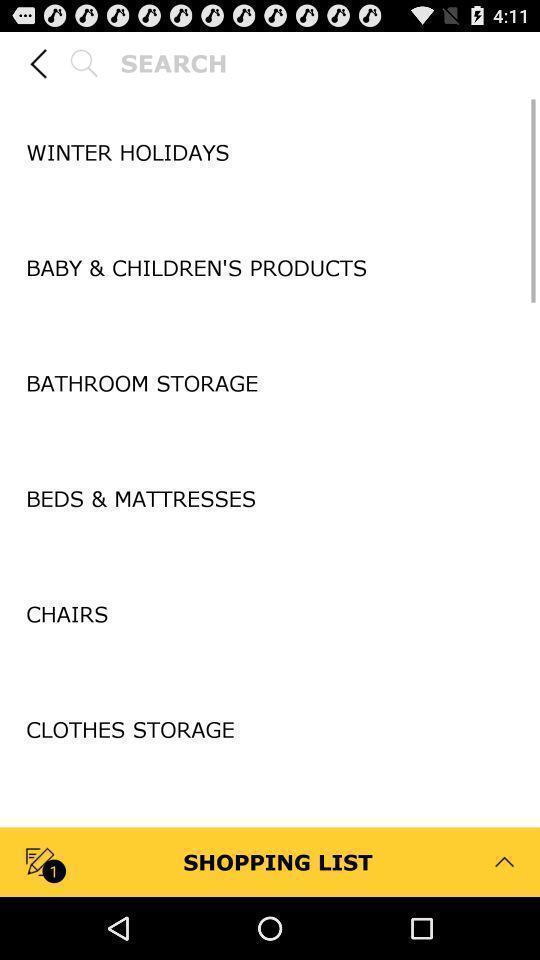What can you discern from this picture? Search bar to search for the products. 